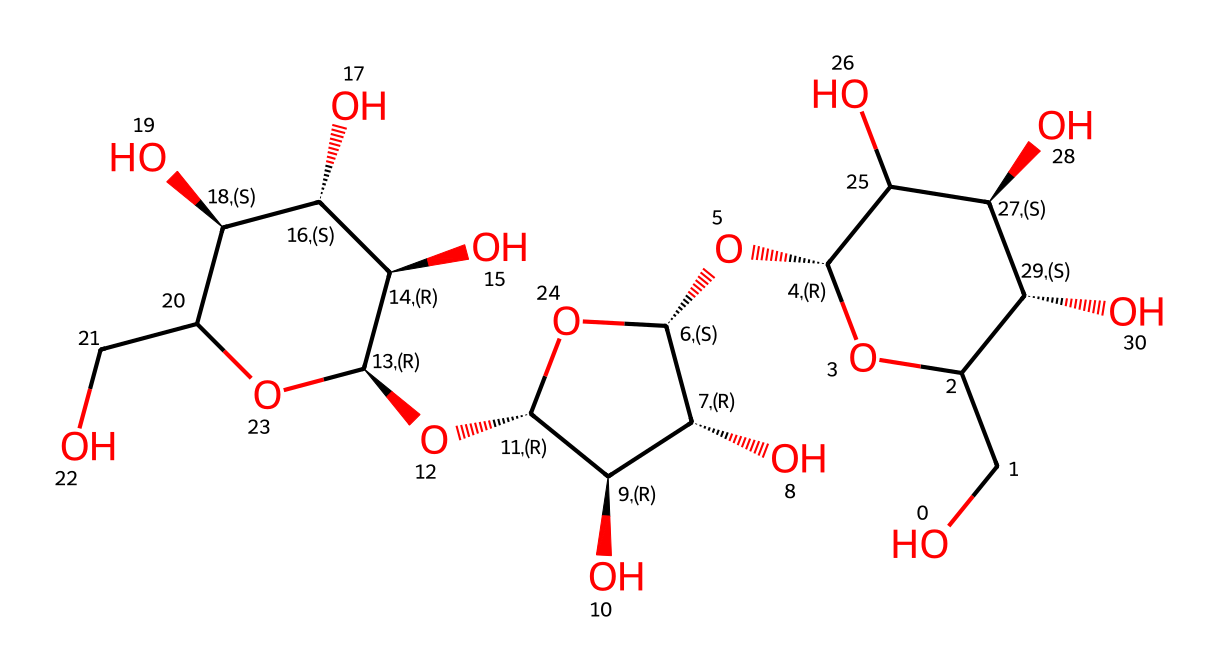What is the molecular formula of cellulose based on this structure? The molecular structure has various carbon (C), hydrogen (H), and oxygen (O) atoms. By counting the atoms indicated in the structure, we find there are 6 carbon atoms, 10 hydrogen atoms, and 5 oxygen atoms suggesting the empirical formula (C6H10O5); however, for the polymer cellulose, it is typically represented as (C6H10O5)n where n represents the number of repeating units.
Answer: C6H10O5 How many pyranose rings are present in this structure? In the visual representation, we can identify the characteristic six-membered cyclic form of glucose, which is known as a pyranose ring. By analyzing the connections and identifying the rings in the structure, we can count three distinct pyranose rings.
Answer: 3 What type of glycosidic linkages are present in cellulose? Observing the connections between the monomer units, we identify that cellulose is made up of glucose units linked together via β-1,4-glycosidic bonds. This specific type of linkage can be deduced from the orientation of the hydroxyl groups during the attachments.
Answer: β-1,4 What is the total number of hydroxyl (-OH) groups in this structure? By carefully examining the structure, we can count the number of hydroxyl functional groups. Hydroxyl groups are indicated by “OH” groups attached to the carbon atoms throughout the structure, and we can identify 10 -OH groups present in this structure.
Answer: 10 Which stereochemistry does the anomeric carbon exhibit in this cellulose structure? Looking at the structure, the anomeric carbon can be identified as the carbon attached to two oxygen atoms, indicating it is in a given stereochemical configuration. In the case of cellulose, the anomeric carbon exhibits the β configuration because the hydroxyl group on that carbon is positioned above the plane of the ring.
Answer: β How many carbon atoms are present in a single repeating unit of cellulose? Analyzing the structure reveals that each monomer unit of cellulose is derived from glucose, and glucose has six carbon atoms. Therefore, in each repeating unit of this cellulose’s chain, there are 6 carbon atoms present.
Answer: 6 